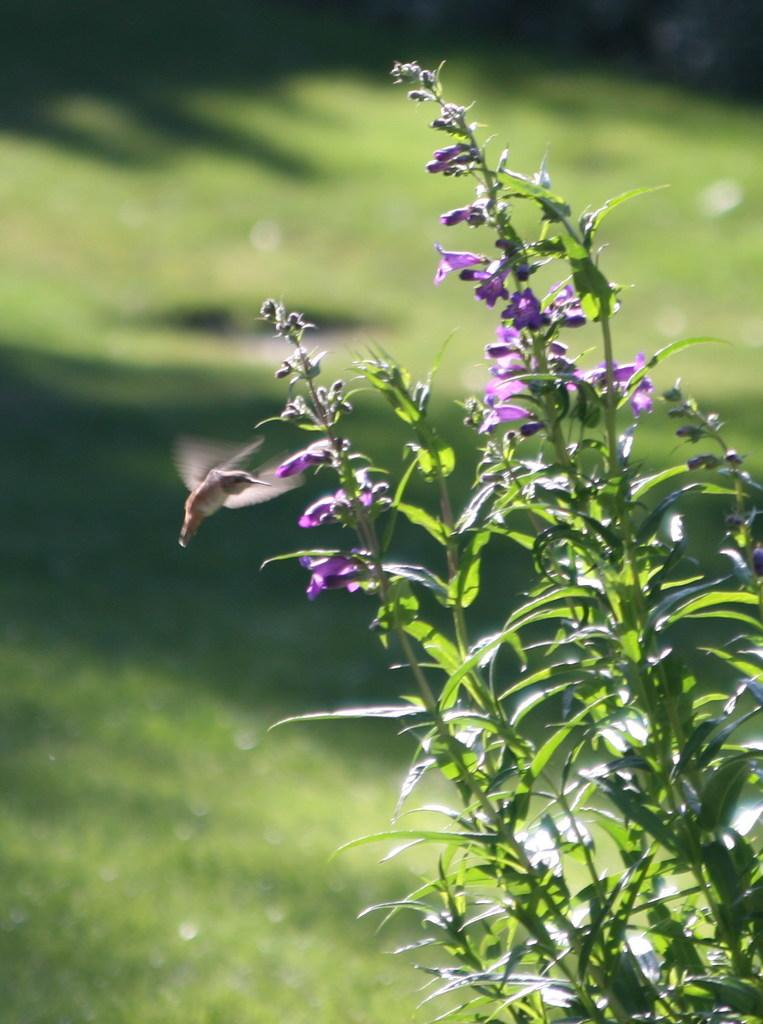What is located in the middle of the image? There are plants, flowers, and stems in the middle of the image. Can you describe the plants in the image? The plants have flowers and stems in the middle of the image. What can be seen in the background of the image? There is greenery in the background of the image. What type of finger can be seen holding a protest sign in the image? There is no finger or protest sign present in the image; it features plants, flowers, and stems. Can you tell me how many frogs are sitting on the flowers in the image? There are no frogs present in the image; it only features plants, flowers, and stems. 